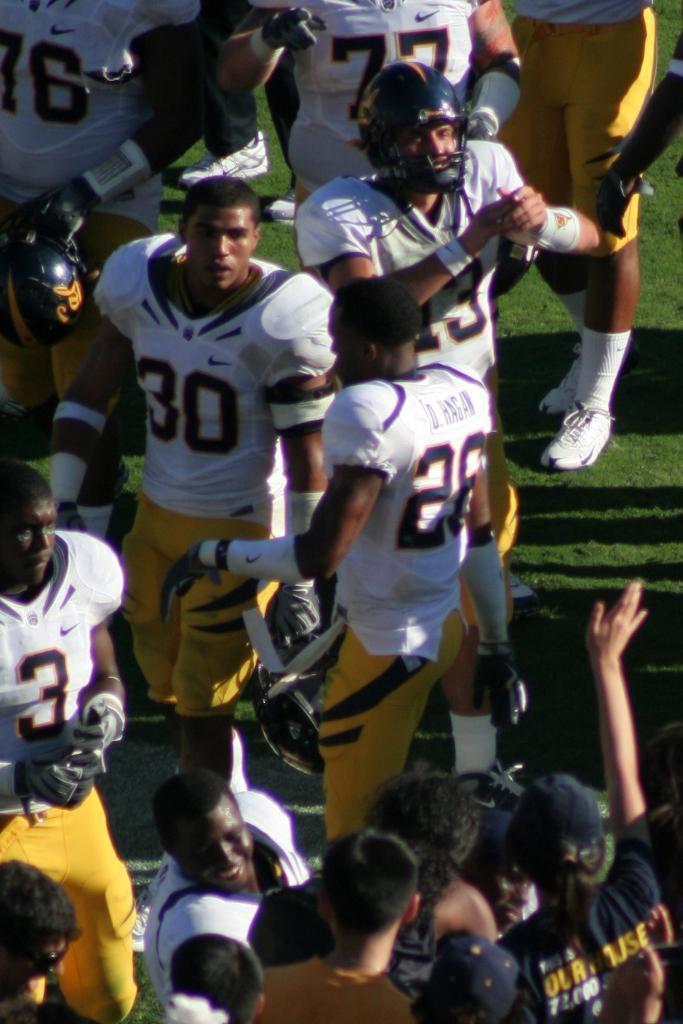How many people are in the image? There are persons in the image. What are the persons wearing? The persons are wearing white and yellow sports dresses. Where are the persons standing? The persons are standing in a ground. What type of comb does the grandmother use in the image? There is no grandmother or comb present in the image. 